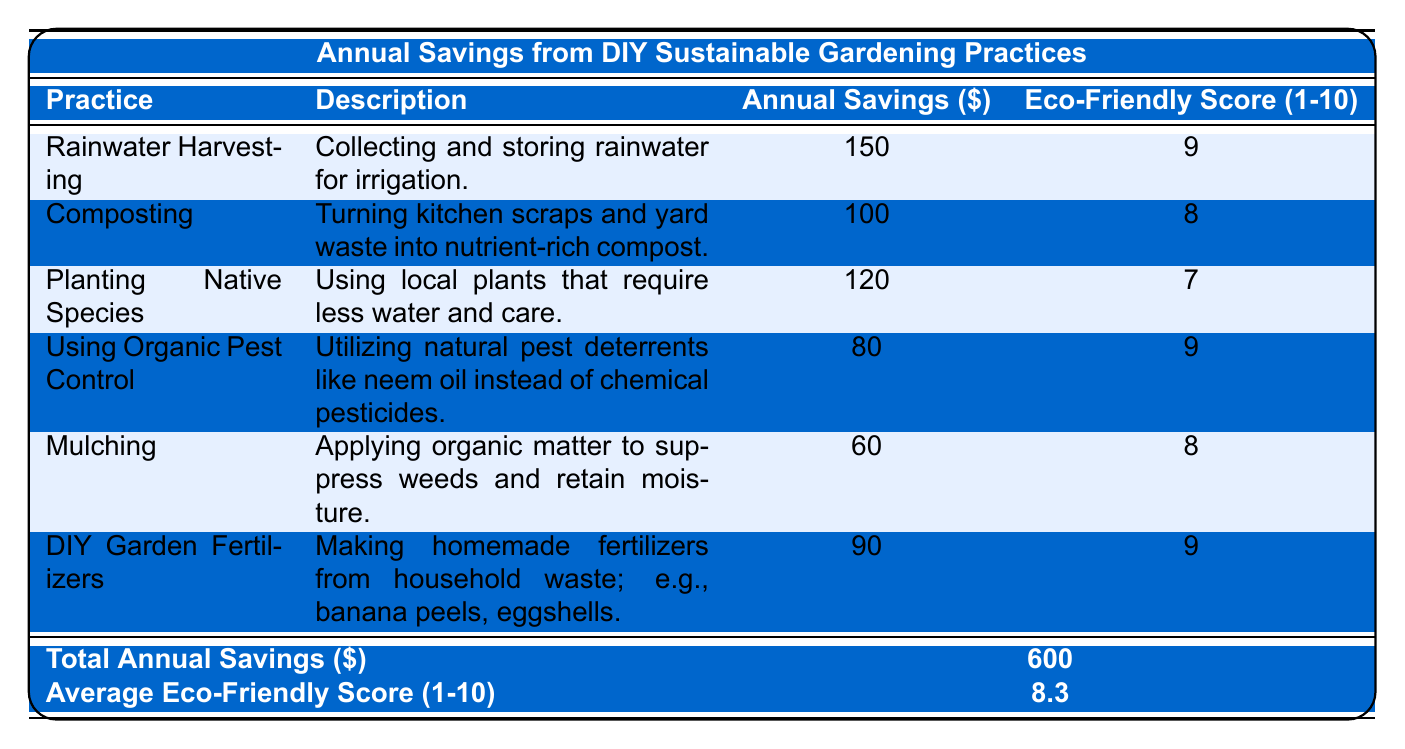What is the annual savings from Rainwater Harvesting? The table lists the annual savings for each gardening practice, and for Rainwater Harvesting, it shows $150.
Answer: 150 Which gardening practice has the highest eco-friendly score? Comparing the eco-friendly scores in the table, Rainwater Harvesting, Using Organic Pest Control, and DIY Garden Fertilizers all have a score of 9, which is the highest.
Answer: Rainwater Harvesting, Using Organic Pest Control, DIY Garden Fertilizers What is the total annual savings from all gardening practices? The total annual savings is explicitly provided in the table as $600.
Answer: 600 How much can one save annually by practicing Composting? The savings from Composting as shown in the table is $100.
Answer: 100 What is the average eco-friendly score across all practices? The average eco-friendly score is provided in the table as 8.3.
Answer: 8.3 What is the difference in annual savings between Planting Native Species and Mulching? Planting Native Species has savings of $120 and Mulching has $60. The difference is $120 - $60 = $60.
Answer: 60 If someone practices all of these gardening techniques, how much can they expect to save? The total annual savings from all practices is $600, as noted in the overall row of the table.
Answer: 600 Is the eco-friendly score for Using Organic Pest Control higher than that of Planting Native Species? Using Organic Pest Control has a score of 9, while Planting Native Species has a score of 7, making it true that Using Organic Pest Control has a higher score.
Answer: Yes What is the sum of annual savings from Mulching and DIY Garden Fertilizers? From the table, Mulching has savings of $60 and DIY Garden Fertilizers has savings of $90. Therefore, the sum is $60 + $90 = $150.
Answer: 150 Which practices have an eco-friendly score of 8 or higher? Looking at the eco-friendly scores, Rainwater Harvesting (9), Using Organic Pest Control (9), Mulching (8), Composting (8), and DIY Garden Fertilizers (9) all have scores of 8 or above.
Answer: Rainwater Harvesting, Using Organic Pest Control, Mulching, Composting, DIY Garden Fertilizers 